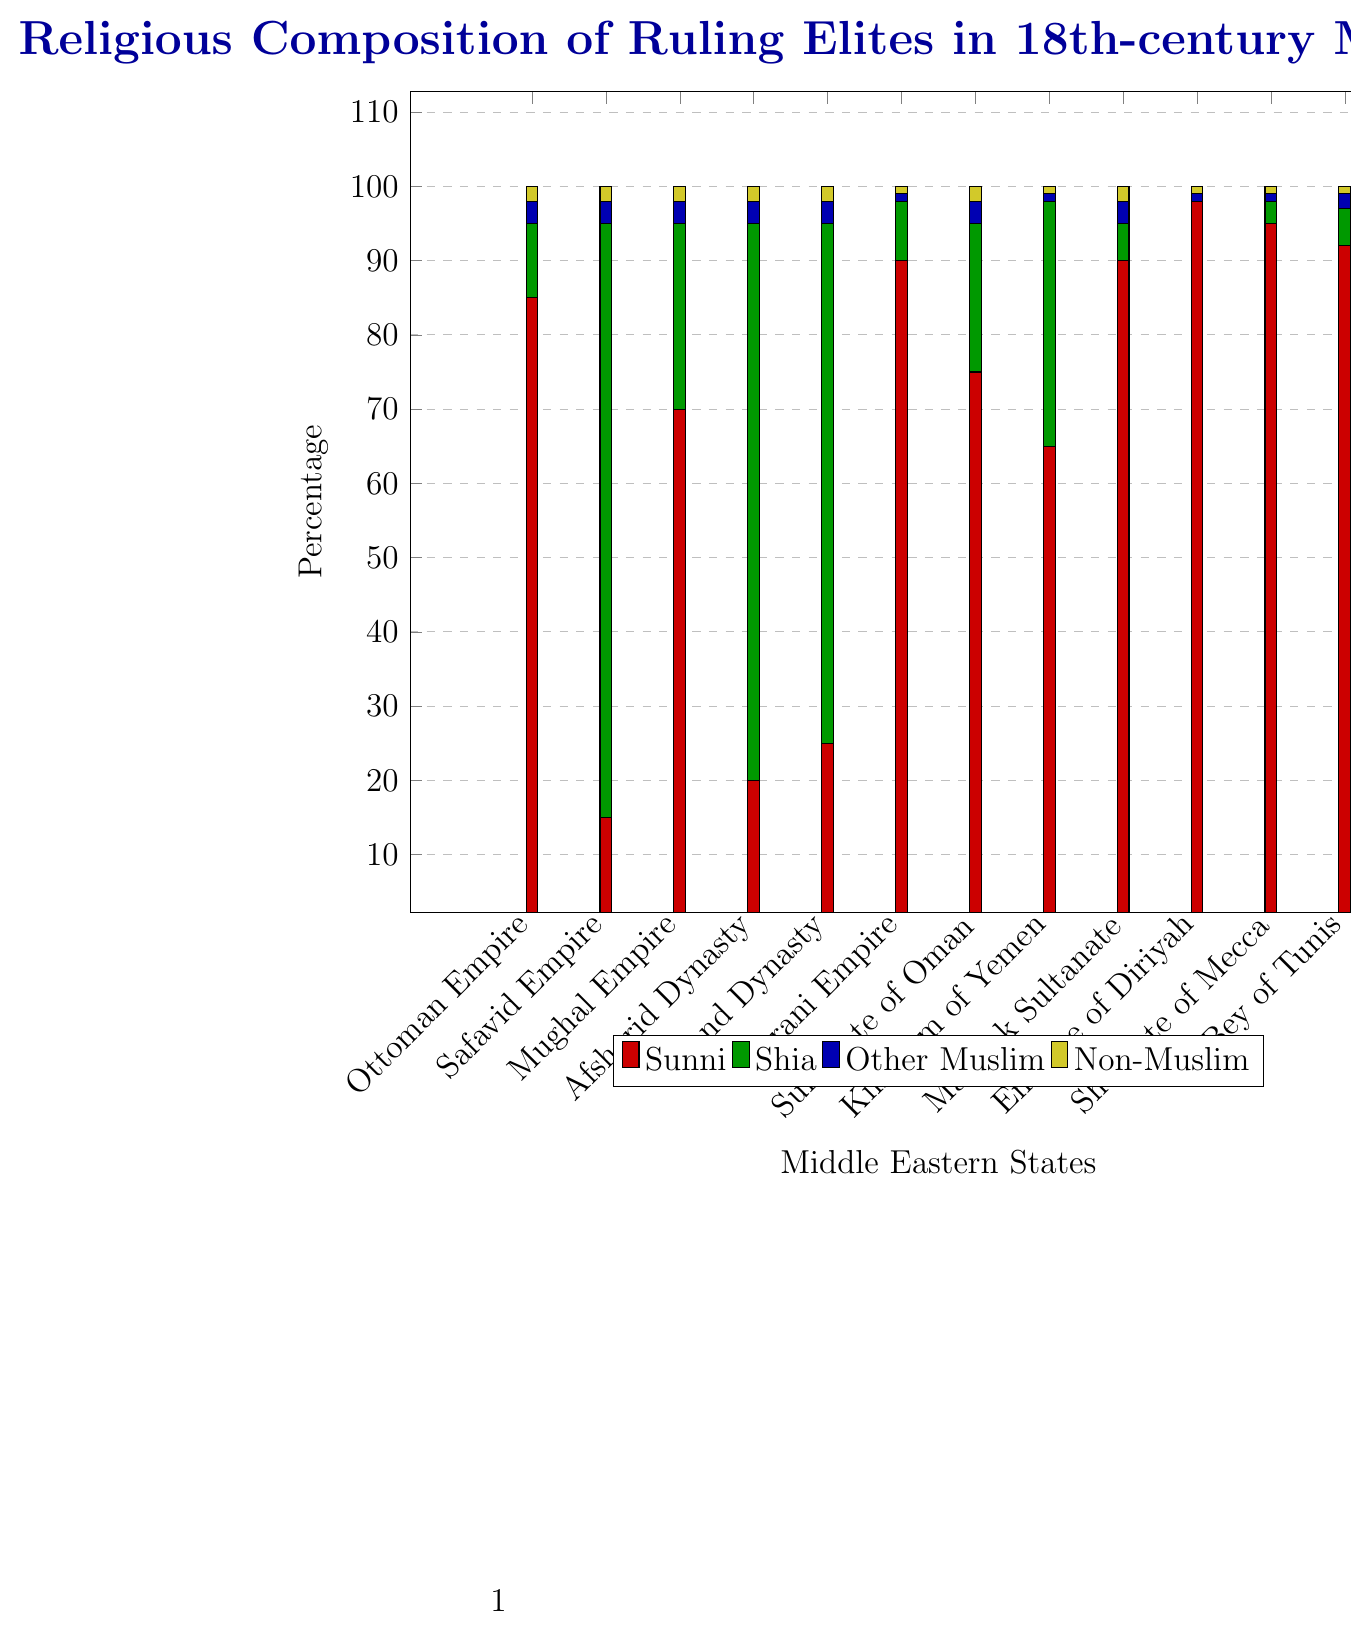Which state has the highest percentage of Sunni ruling elite? The state with the highest percentage of Sunni ruling elite can be identified by looking for the tallest red section in the bar chart, which represents Sunni percentage. The Emirate of Diriyah has the tallest red section, with 98% Sunni ruling elite.
Answer: Emirate of Diriyah Which state has the highest percentage of Shia ruling elite? The state with the highest percentage of Shia ruling elite can be identified by looking for the tallest green section in the bar chart, which represents Shia percentage. The Safavid Empire has the tallest green section, with 80% Shia ruling elite.
Answer: Safavid Empire How do the percentages of Non-Muslim ruling elites compare between the state with the highest Sunni percentage and the state with the highest Shia percentage? The Non-Muslim percentage can be identified by the yellow section. The Emirate of Diriyah (highest Sunni percentage) has 1% Non-Muslim ruling elite, while the Safavid Empire (highest Shia percentage) has 2% Non-Muslim ruling elite.
Answer: Emirate of Diriyah: 1%, Safavid Empire: 2% What is the combined total percentage of Sunni and Shia in the Mughal Empire? To find the total percentage of Sunni and Shia, add the percentages for both groups in the Mughal Empire: 70% Sunni + 25% Shia = 95%.
Answer: 95% Rank the states in descending order of the percentage of Sunni ruling elites. Order the states by the height of their red sections, from highest to lowest: Emirate of Diriyah (98%), Sharifate of Mecca (95%), Bey of Tunis (92%), Durrani Empire (90%), Mamluk Sultanate (90%), Sultanate of Oman (75%), Mughal Empire (70%), Ottoman Empire (85%), Kingdom of Yemen (65%), Zand Dynasty (25%), Afsharid Dynasty (20%), Safavid Empire (15%).
Answer: Emirate of Diriyah, Sharifate of Mecca, Bey of Tunis, Durrani Empire, Mamluk Sultanate, Sultanate of Oman, Mughal Empire, Ottoman Empire, Kingdom of Yemen, Zand Dynasty, Afsharid Dynasty, Safavid Empire What is the average percentage of Sunni ruling elites across all the states shown? Sum the Sunni percentages of all the states and then divide by the number of states. (85+15+70+20+25+90+75+65+90+98+95+92)/12 = 809/12 ≈ 67.42.
Answer: ≈ 67.42% Identify the states with no Shia ruling elite. The states with no green sections in the bar chart are the ones without Shia ruling elite. The Emirate of Diriyah has 0% of Shia ruling elite.
Answer: Emirate of Diriyah Compare the percentage of Other Muslim ruling elites between the Zand Dynasty and the Sultanate of Oman. Which state has more? The percentage of Other Muslim ruling elites is shown in blue. Both the Zand Dynasty and the Sultanate of Oman have 3% Other Muslim ruling elites.
Answer: Both have 3% 